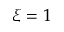<formula> <loc_0><loc_0><loc_500><loc_500>\xi = 1</formula> 